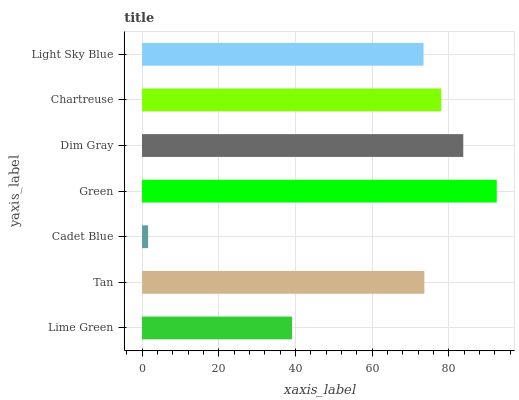Is Cadet Blue the minimum?
Answer yes or no. Yes. Is Green the maximum?
Answer yes or no. Yes. Is Tan the minimum?
Answer yes or no. No. Is Tan the maximum?
Answer yes or no. No. Is Tan greater than Lime Green?
Answer yes or no. Yes. Is Lime Green less than Tan?
Answer yes or no. Yes. Is Lime Green greater than Tan?
Answer yes or no. No. Is Tan less than Lime Green?
Answer yes or no. No. Is Tan the high median?
Answer yes or no. Yes. Is Tan the low median?
Answer yes or no. Yes. Is Green the high median?
Answer yes or no. No. Is Dim Gray the low median?
Answer yes or no. No. 